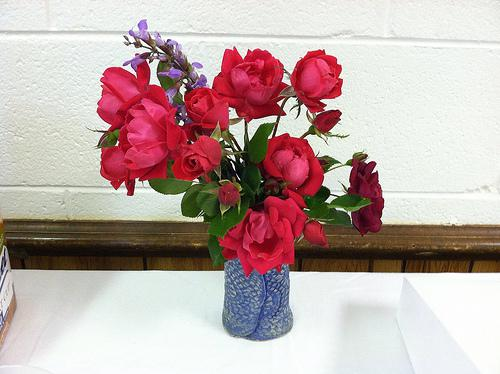Question: how many vases on the table?
Choices:
A. Two.
B. One.
C. Six.
D. Twelve.
Answer with the letter. Answer: B Question: where are the flowers?
Choices:
A. On the table.
B. In the vase.
C. Growing in the ground.
D. In the garden.
Answer with the letter. Answer: B Question: what is in the vase?
Choices:
A. Plants.
B. Dead flowers.
C. Roses.
D. Flowers.
Answer with the letter. Answer: D Question: what is the color of the flowers?
Choices:
A. Blue.
B. Purple.
C. Orange and white.
D. Red and violet.
Answer with the letter. Answer: D Question: when did the flowers arranged?
Choices:
A. Last week.
B. Just now.
C. This morning.
D. Last night.
Answer with the letter. Answer: B 